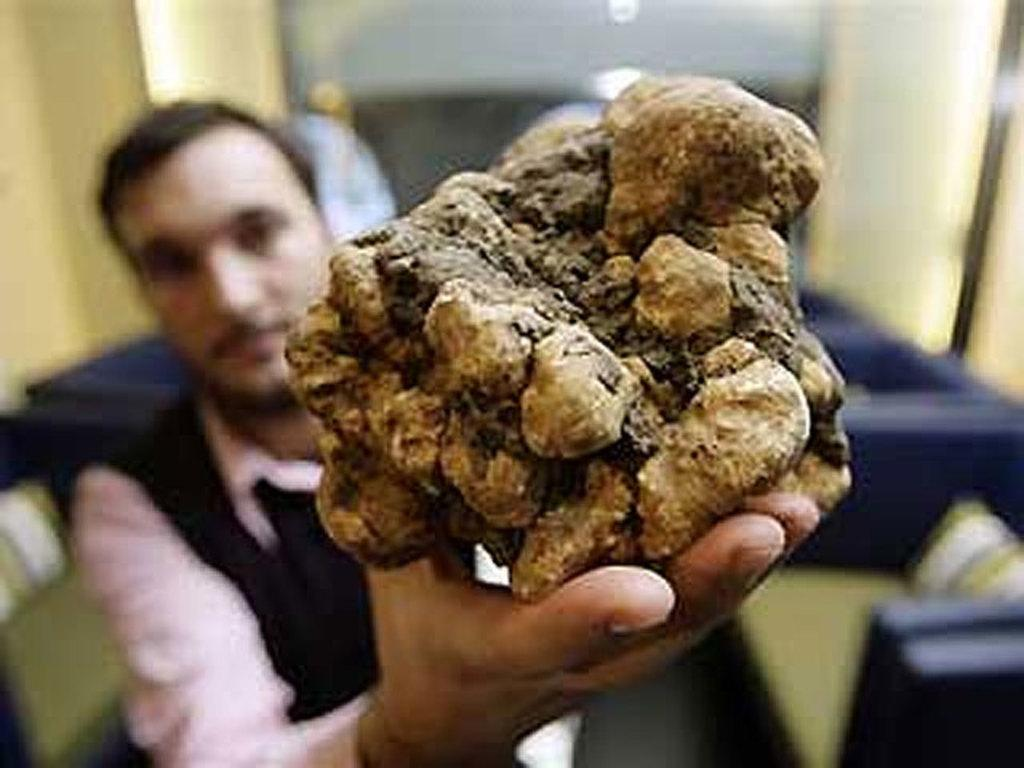What is the man in the image holding? The man is holding an object in the image. Can you describe the background of the image? The background of the image is blurred. What type of furniture can be seen in the image? There are chairs in the image. What type of seating accessory is present in the image? There are cushions in the image. What type of straw is the robin using to build its nest in the image? There is no robin or nest present in the image, so it is not possible to determine what type of straw might be used. 